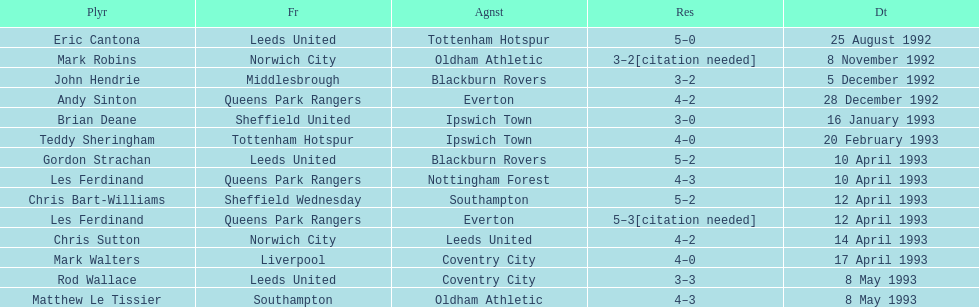Name the players for tottenham hotspur. Teddy Sheringham. 